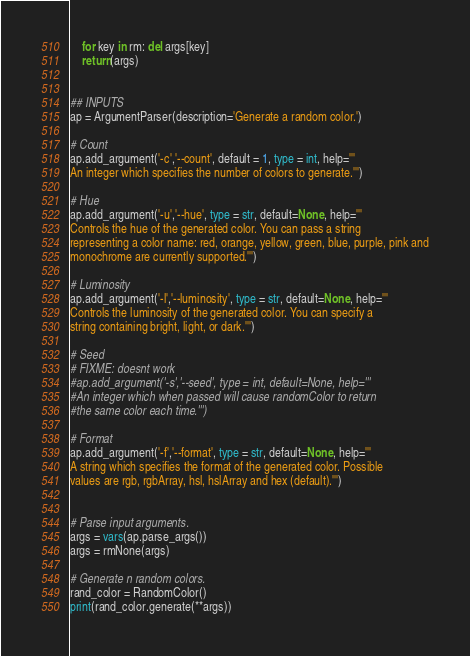Convert code to text. <code><loc_0><loc_0><loc_500><loc_500><_Python_>    for key in rm: del args[key]
    return(args)


## INPUTS
ap = ArgumentParser(description='Generate a random color.')

# Count
ap.add_argument('-c','--count', default = 1, type = int, help='''
An integer which specifies the number of colors to generate.''')

# Hue
ap.add_argument('-u','--hue', type = str, default=None, help='''
Controls the hue of the generated color. You can pass a string
representing a color name: red, orange, yellow, green, blue, purple, pink and
monochrome are currently supported.''')

# Luminosity
ap.add_argument('-l','--luminosity', type = str, default=None, help='''
Controls the luminosity of the generated color. You can specify a
string containing bright, light, or dark.''')

# Seed
# FIXME: doesnt work
#ap.add_argument('-s','--seed', type = int, default=None, help='''
#An integer which when passed will cause randomColor to return
#the same color each time.''')

# Format
ap.add_argument('-f','--format', type = str, default=None, help='''
A string which specifies the format of the generated color. Possible
values are rgb, rgbArray, hsl, hslArray and hex (default).''')


# Parse input arguments.
args = vars(ap.parse_args())
args = rmNone(args)

# Generate n random colors.
rand_color = RandomColor()
print(rand_color.generate(**args))
</code> 